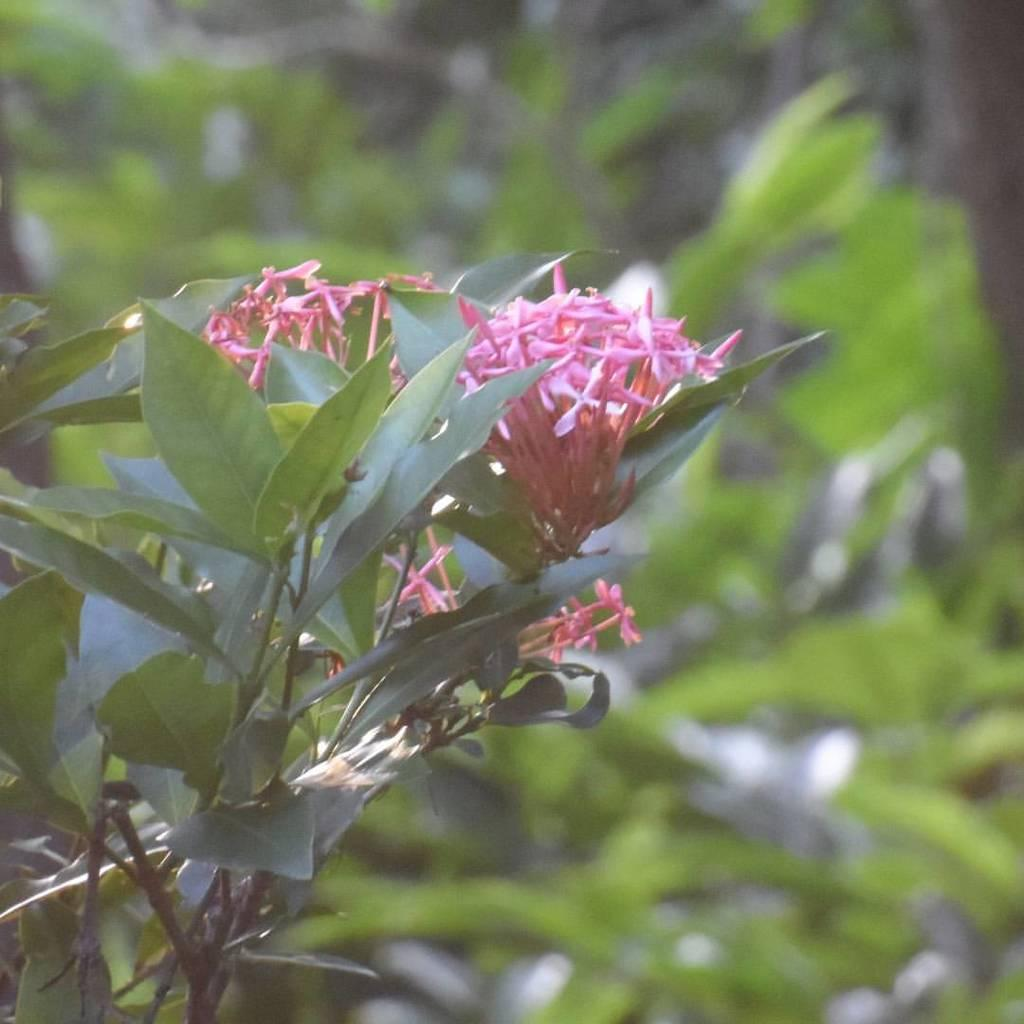What type of plant is visible in the image? There is a plant in the image. What additional features can be seen on the plant? There are flowers on the plant. What can be seen in the background of the image? There are leaves in the background of the image. How would you describe the background of the image? The background appears blurry. What type of roof can be seen on the plant in the image? There is no roof present in the image; it features a plant with flowers and leaves in the background. What emotion does the plant appear to be experiencing in the image? Plants do not experience emotions, so it is not possible to determine the emotion of the plant in the image. 